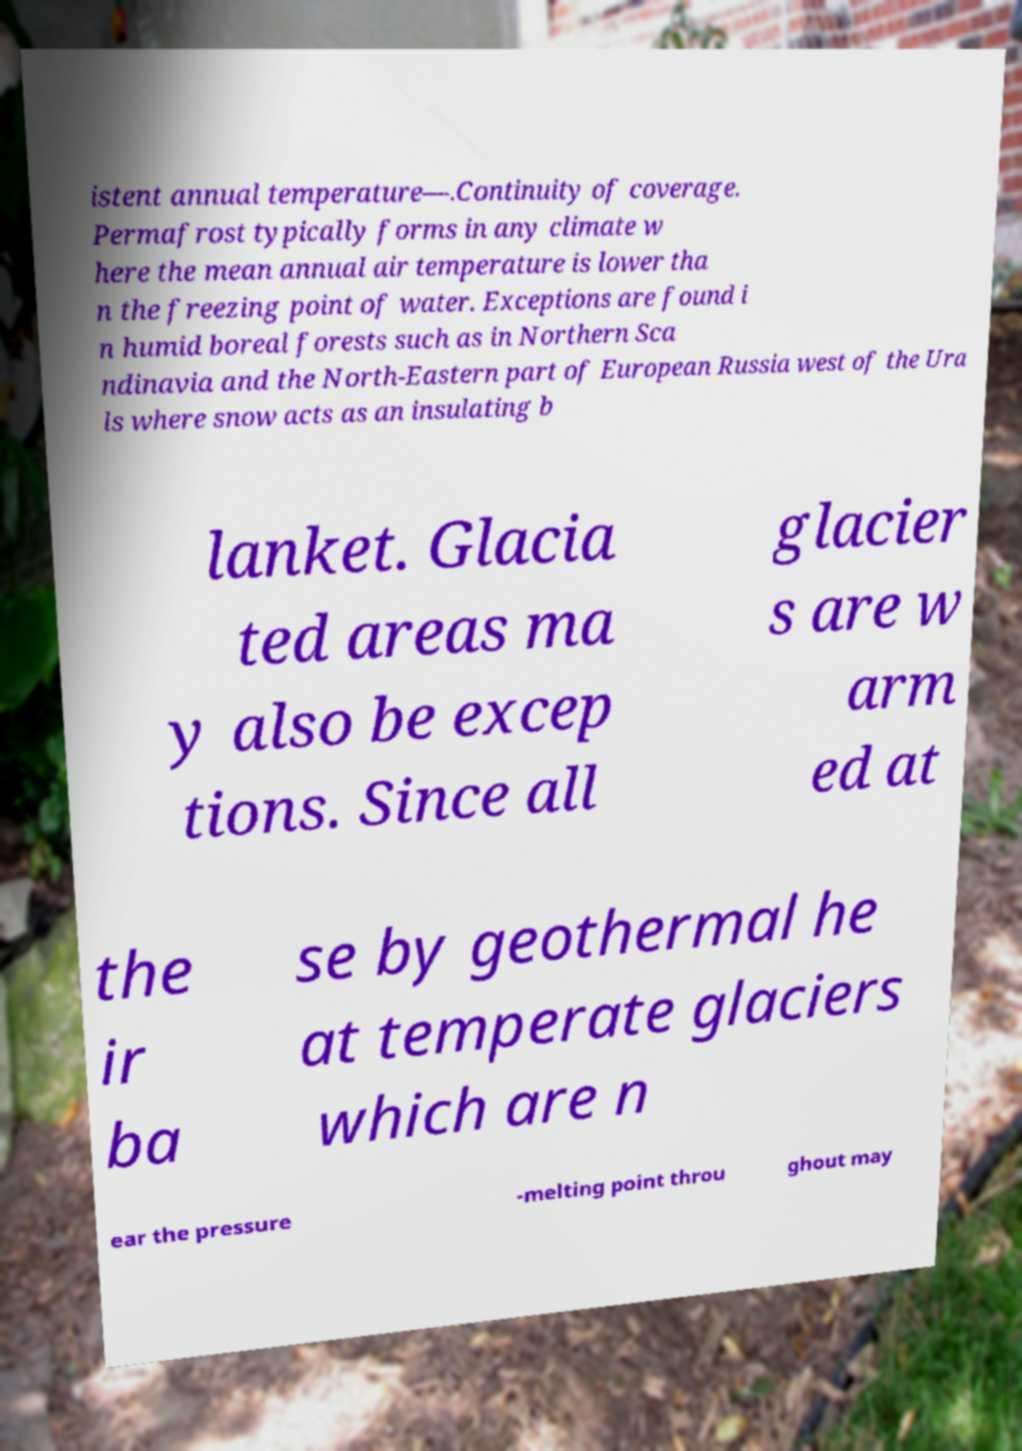I need the written content from this picture converted into text. Can you do that? istent annual temperature—.Continuity of coverage. Permafrost typically forms in any climate w here the mean annual air temperature is lower tha n the freezing point of water. Exceptions are found i n humid boreal forests such as in Northern Sca ndinavia and the North-Eastern part of European Russia west of the Ura ls where snow acts as an insulating b lanket. Glacia ted areas ma y also be excep tions. Since all glacier s are w arm ed at the ir ba se by geothermal he at temperate glaciers which are n ear the pressure -melting point throu ghout may 